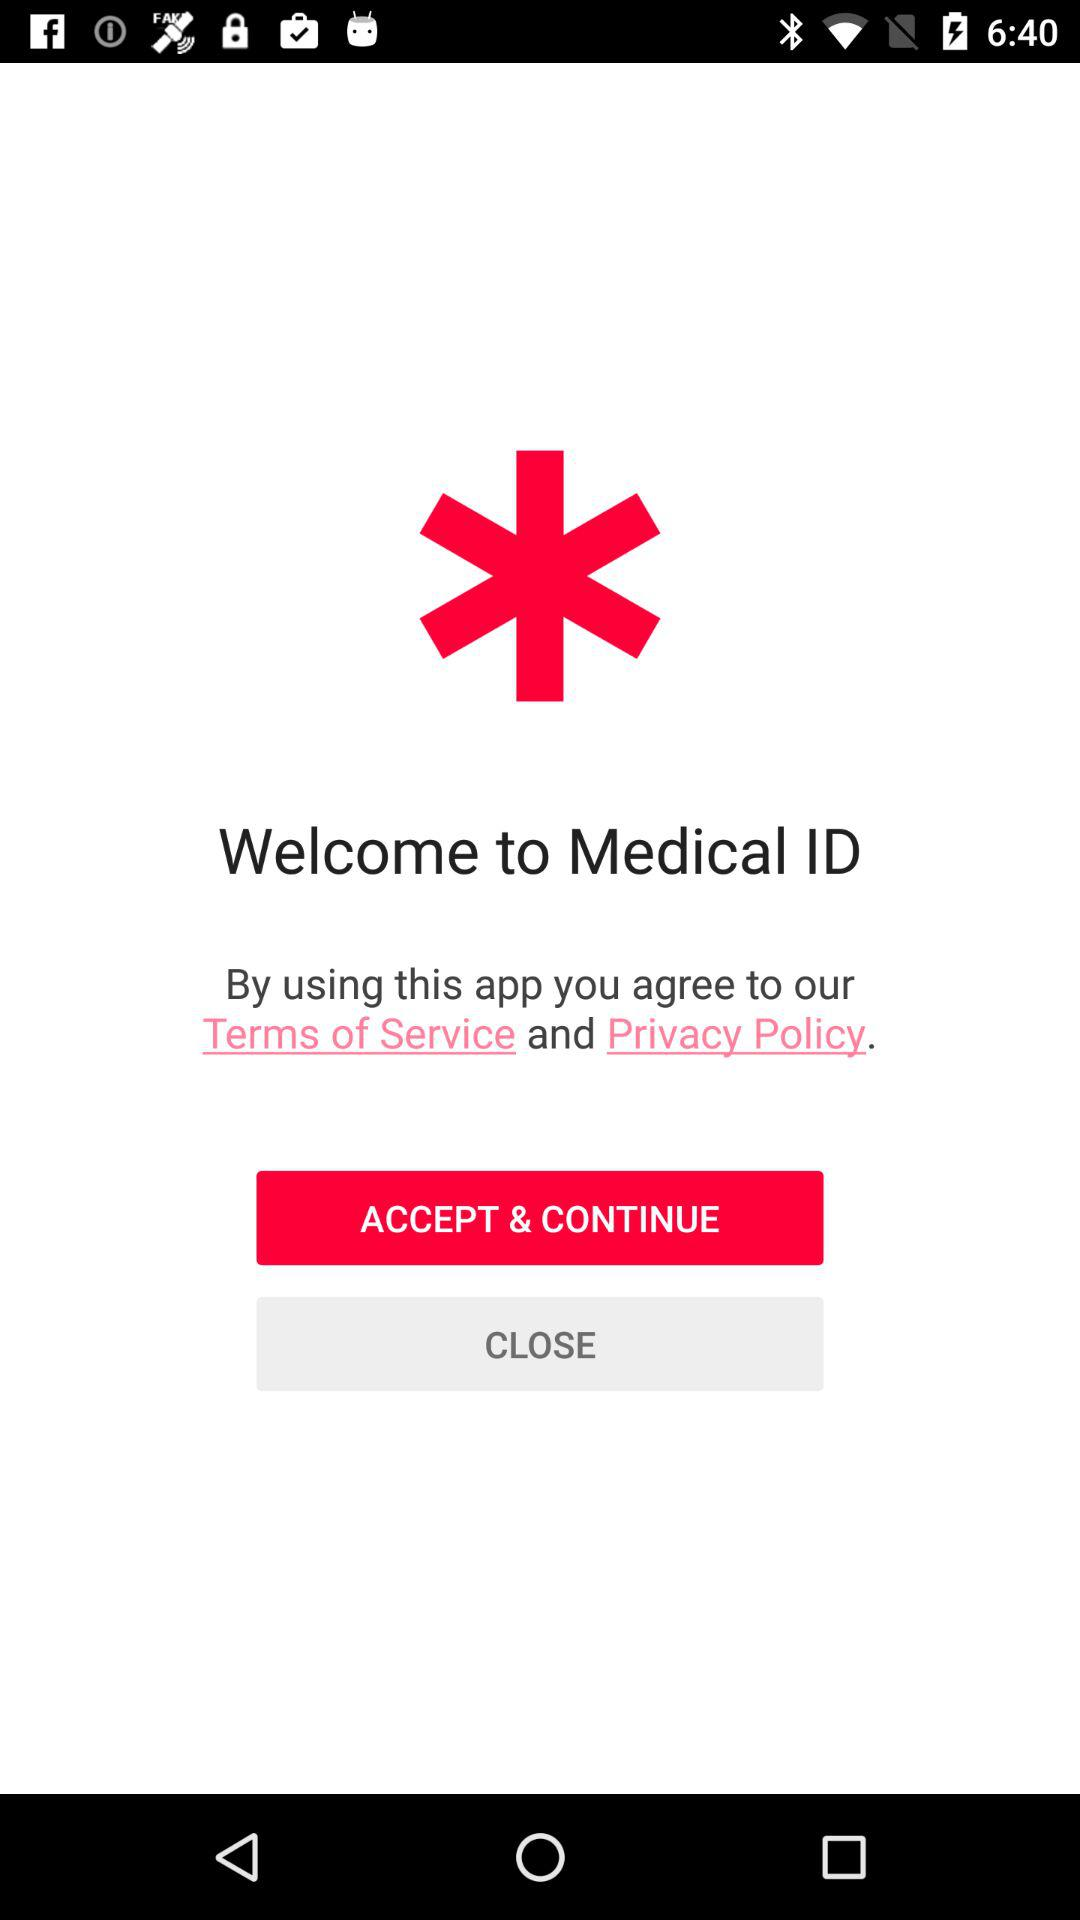What is the application name? The application name is "Medical ID". 